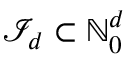Convert formula to latex. <formula><loc_0><loc_0><loc_500><loc_500>{ \mathcal { I } } _ { d } \subset { \mathbb { N } } _ { 0 } ^ { d }</formula> 